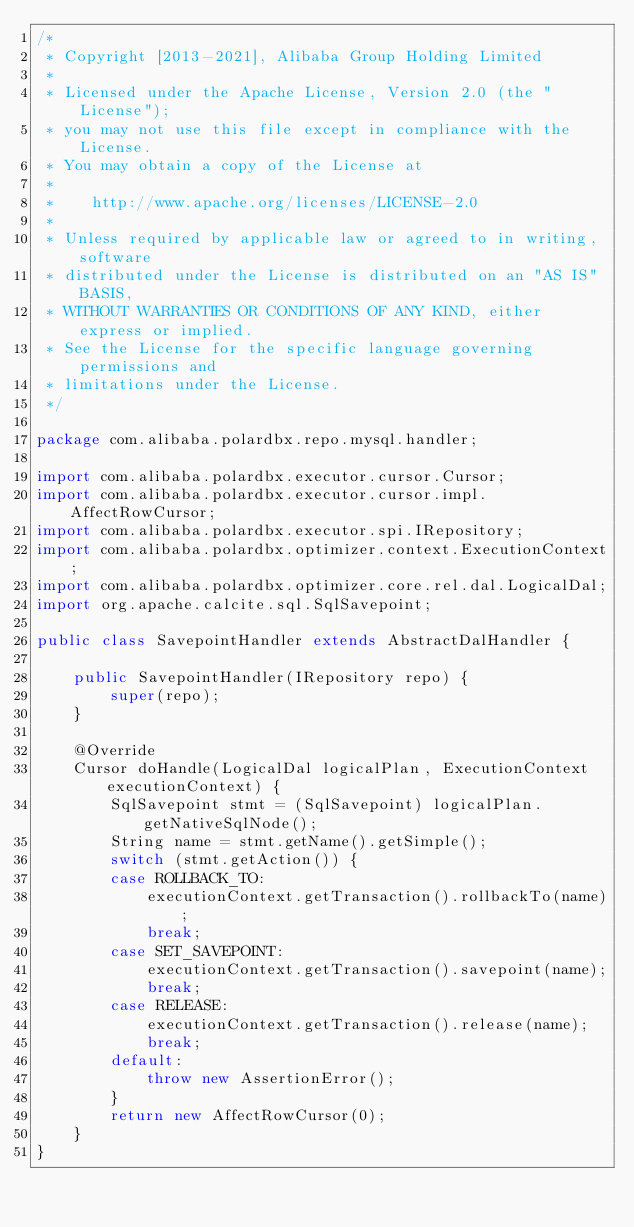Convert code to text. <code><loc_0><loc_0><loc_500><loc_500><_Java_>/*
 * Copyright [2013-2021], Alibaba Group Holding Limited
 *
 * Licensed under the Apache License, Version 2.0 (the "License");
 * you may not use this file except in compliance with the License.
 * You may obtain a copy of the License at
 *
 *    http://www.apache.org/licenses/LICENSE-2.0
 *
 * Unless required by applicable law or agreed to in writing, software
 * distributed under the License is distributed on an "AS IS" BASIS,
 * WITHOUT WARRANTIES OR CONDITIONS OF ANY KIND, either express or implied.
 * See the License for the specific language governing permissions and
 * limitations under the License.
 */

package com.alibaba.polardbx.repo.mysql.handler;

import com.alibaba.polardbx.executor.cursor.Cursor;
import com.alibaba.polardbx.executor.cursor.impl.AffectRowCursor;
import com.alibaba.polardbx.executor.spi.IRepository;
import com.alibaba.polardbx.optimizer.context.ExecutionContext;
import com.alibaba.polardbx.optimizer.core.rel.dal.LogicalDal;
import org.apache.calcite.sql.SqlSavepoint;

public class SavepointHandler extends AbstractDalHandler {

    public SavepointHandler(IRepository repo) {
        super(repo);
    }

    @Override
    Cursor doHandle(LogicalDal logicalPlan, ExecutionContext executionContext) {
        SqlSavepoint stmt = (SqlSavepoint) logicalPlan.getNativeSqlNode();
        String name = stmt.getName().getSimple();
        switch (stmt.getAction()) {
        case ROLLBACK_TO:
            executionContext.getTransaction().rollbackTo(name);
            break;
        case SET_SAVEPOINT:
            executionContext.getTransaction().savepoint(name);
            break;
        case RELEASE:
            executionContext.getTransaction().release(name);
            break;
        default:
            throw new AssertionError();
        }
        return new AffectRowCursor(0);
    }
}
</code> 